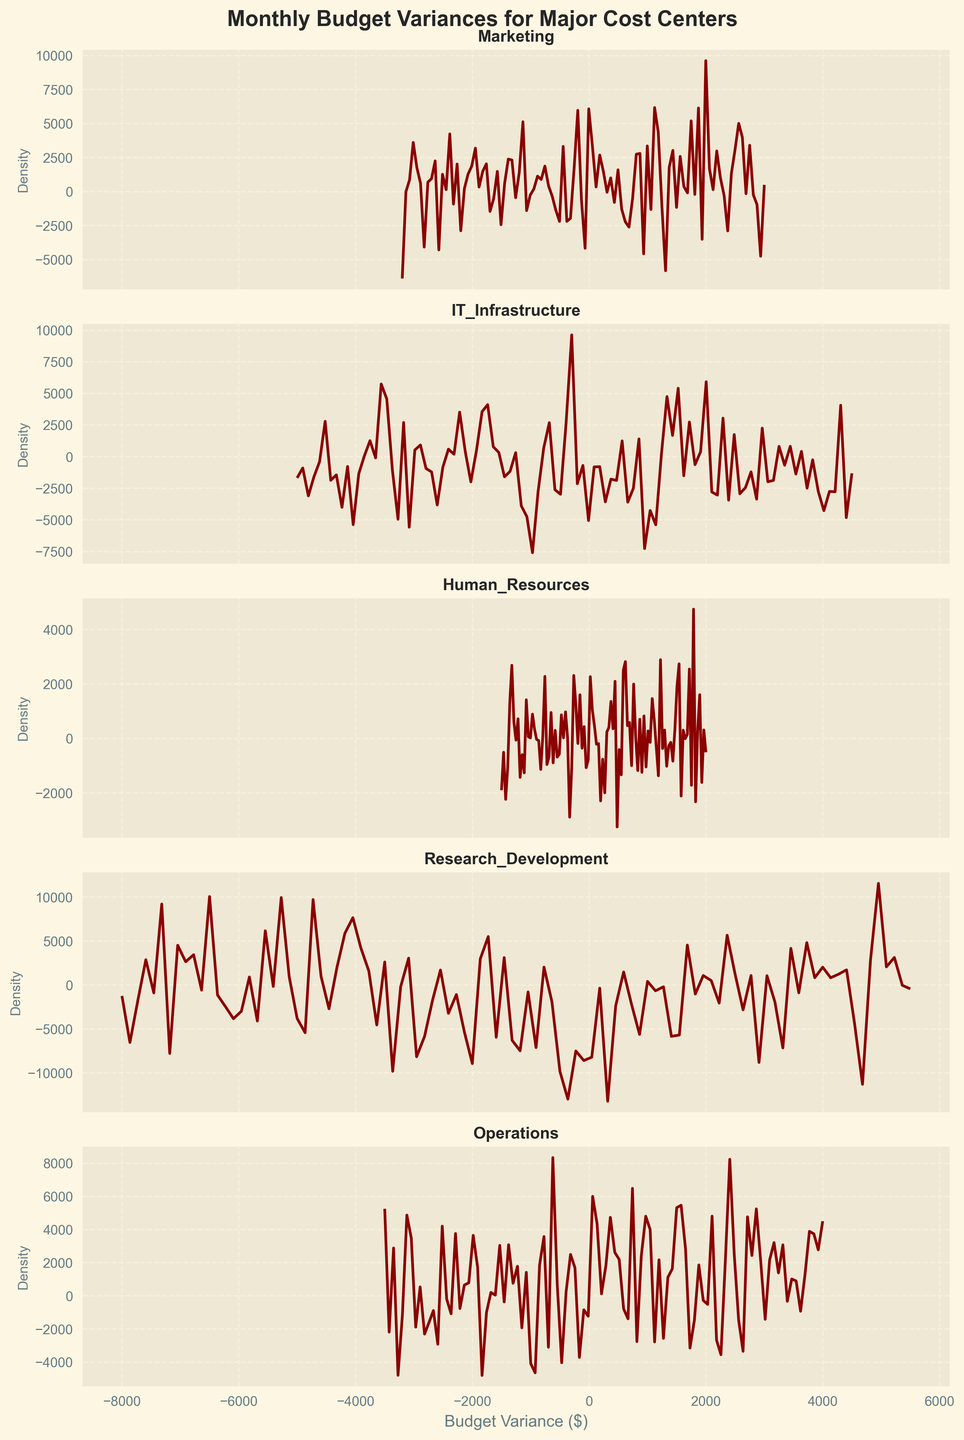What's the title of the plot? The title of the plot is clearly indicated at the top of the figure.
Answer: Monthly Budget Variances for Major Cost Centers Which cost center shows a wide spread of budget variance? The degree of spread can be seen from the width of the histogram and KDE plot. A wide spread indicates more variance.
Answer: Research & Development What is the title of the x-axis? The title of the x-axis is found at the bottom of the subplots.
Answer: Budget Variance ($) Can you identify a cost center with mainly positive budget variances? By observing the histograms and density plots, look for a cost center where the majority of the values lie above 0.
Answer: Operations Do any cost centers have a predominantly negative budget variance distribution? Check the histograms and KDE plots for cost centers where most values are below 0.
Answer: IT Infrastructure Which cost center has the smallest average budget variance? Compare the central tendency of the KDE plots to find the smallest average variance.
Answer: Human Resources Between 'Marketing' and 'IT Infrastructure', which cost center has a higher density peak? Compare the density peaks (the highest points on the KDE plot) between the two cost centers.
Answer: IT Infrastructure Which cost center shows a bimodal distribution in budget variances? Look for a histogram or KDE plot with two distinct peaks.
Answer: Research & Development How many unique cost centers are displayed in the subplots? Count the number of individual subplots, each representing a cost center.
Answer: Five Which cost center has a budget variance distribution that includes a large positive outlier? Identify the cost center with a significant positive outlier indicated by an extended tail or isolated histogram bars.
Answer: Research & Development 